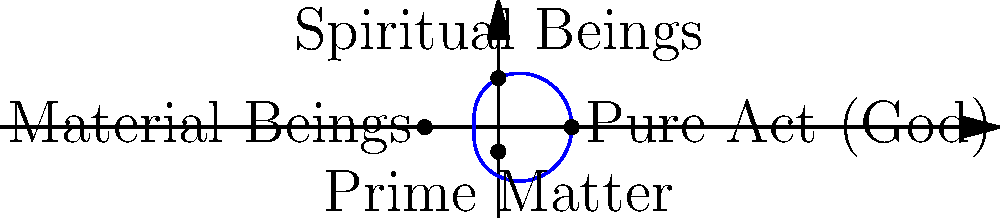In Thomistic metaphysics, the levels of being can be represented by a limacon. Which point on the limacon corresponds to the highest level of being, Pure Act (God), and why is this representation appropriate? To understand this representation, let's consider the following steps:

1. In Thomistic metaphysics, there are four main levels of being:
   a) Pure Act (God)
   b) Spiritual Beings (angels)
   c) Material Beings (humans, animals, plants)
   d) Prime Matter (potential for material existence)

2. The limacon is described by the polar equation $r = a + b \cos(\theta)$, where $a$ and $b$ are constants.

3. In this representation:
   a) The outermost point $(3,0)$ corresponds to Pure Act (God)
   b) The top point $(0,2)$ represents Spiritual Beings
   c) The leftmost point $(-3,0)$ represents Material Beings
   d) The inner loop's bottom point $(0,-1)$ represents Prime Matter

4. The point $(3,0)$ is the farthest from the origin, representing the highest level of being (Pure Act).

5. This representation is appropriate because:
   a) The continuous nature of the limacon reflects the continuity of being in Thomistic thought.
   b) The varying distance from the origin represents the hierarchy of beings.
   c) The inner loop can be seen as representing potentiality, while the outer loop represents actuality.
   d) The symmetry of the limacon reflects the ordered nature of creation in Thomistic philosophy.

Therefore, the point $(3,0)$ on the limacon, being the farthest from the origin, appropriately represents Pure Act (God) as the highest level of being in Thomistic metaphysics.
Answer: $(3,0)$, as it's farthest from the origin, representing the highest level of being (Pure Act). 